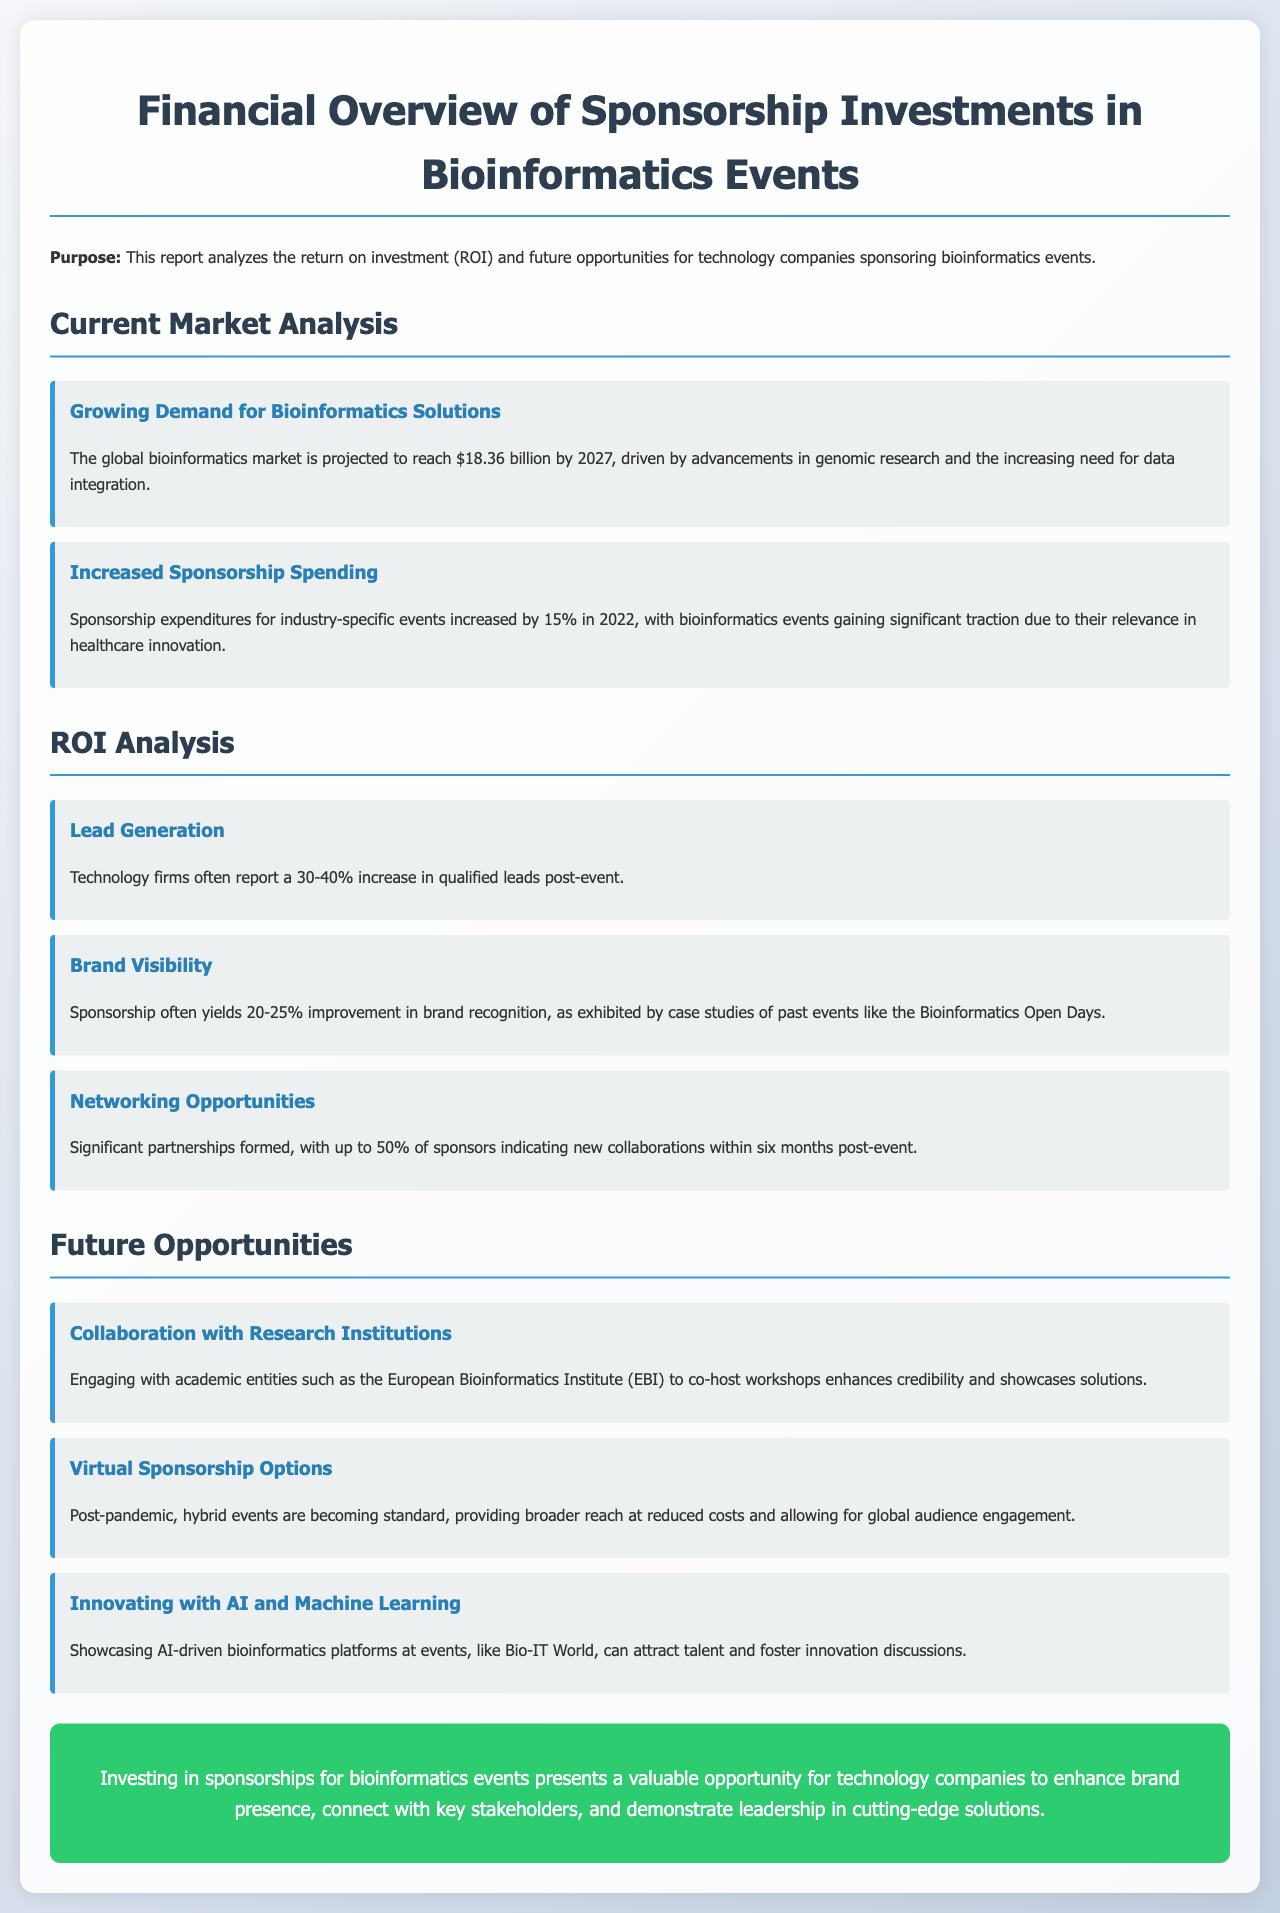What is the projected size of the global bioinformatics market by 2027? The document states that the global bioinformatics market is projected to reach $18.36 billion by 2027.
Answer: $18.36 billion What is the increase in sponsorship expenditures in 2022? It mentions that sponsorship expenditures for industry-specific events increased by 15% in 2022.
Answer: 15% What percentage increase in qualified leads do technology firms report post-event? According to the document, technology firms often report a 30-40% increase in qualified leads post-event.
Answer: 30-40% What is one benefit of sponsorship related to brand visibility? The document indicates that sponsorship often yields a 20-25% improvement in brand recognition.
Answer: 20-25% Which institution is suggested for collaboration to enhance credibility? The report recommends engaging with the European Bioinformatics Institute (EBI) to co-host workshops.
Answer: European Bioinformatics Institute (EBI) What type of events are becoming standard post-pandemic? The document states that hybrid events are becoming standard post-pandemic.
Answer: Hybrid events What percentage of sponsors indicated new collaborations within six months post-event? It mentions that up to 50% of sponsors indicated new collaborations within six months post-event.
Answer: 50% Which event is mentioned as a platform to showcase AI-driven bioinformatics platforms? The document refers to Bio-IT World as an event to showcase AI-driven bioinformatics platforms.
Answer: Bio-IT World 